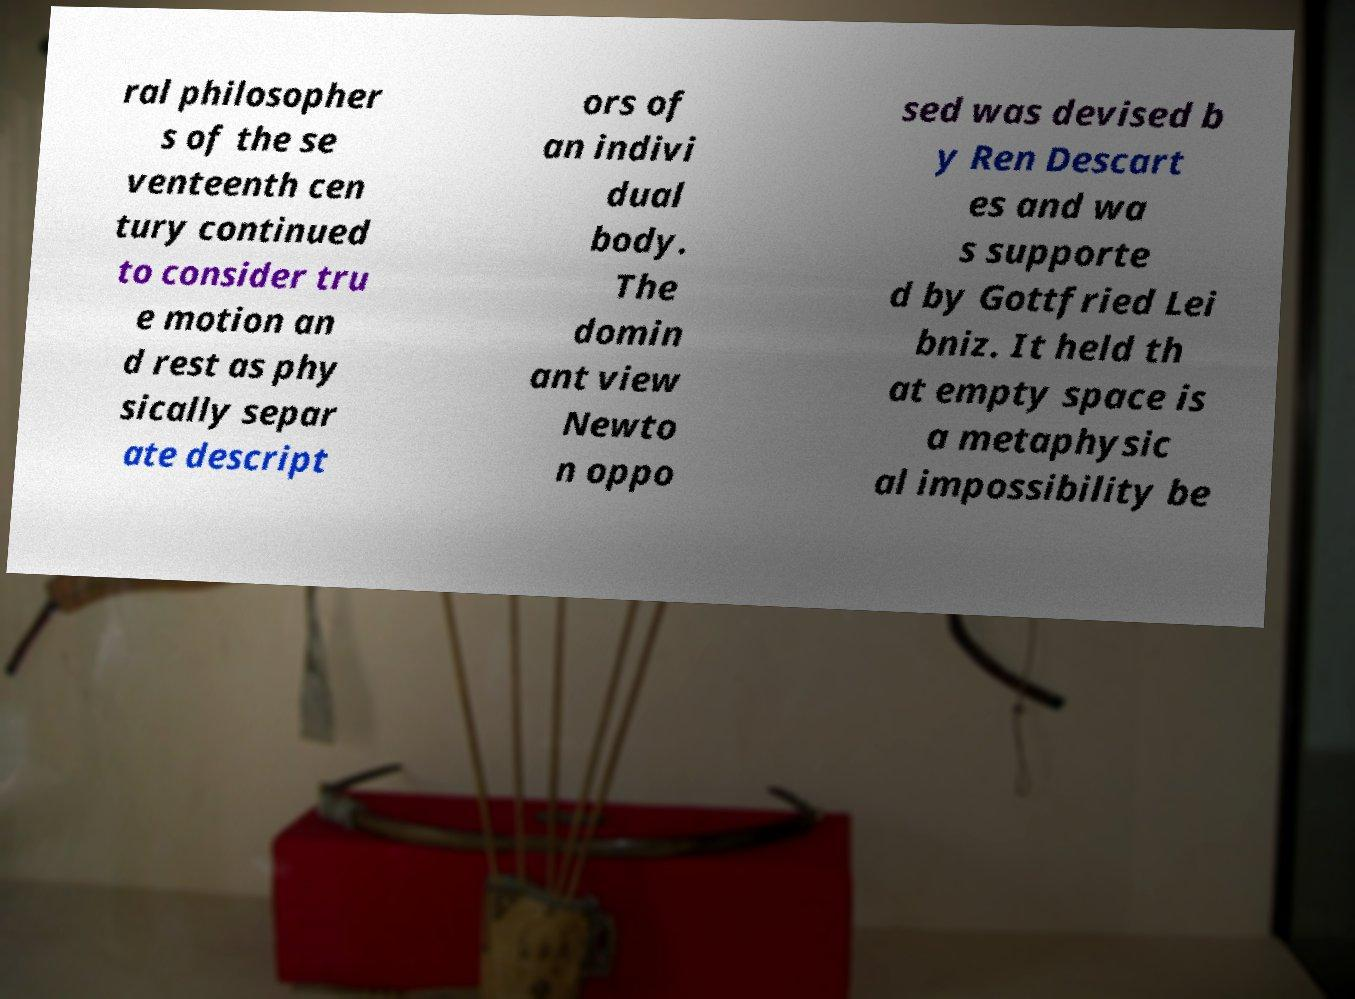There's text embedded in this image that I need extracted. Can you transcribe it verbatim? ral philosopher s of the se venteenth cen tury continued to consider tru e motion an d rest as phy sically separ ate descript ors of an indivi dual body. The domin ant view Newto n oppo sed was devised b y Ren Descart es and wa s supporte d by Gottfried Lei bniz. It held th at empty space is a metaphysic al impossibility be 